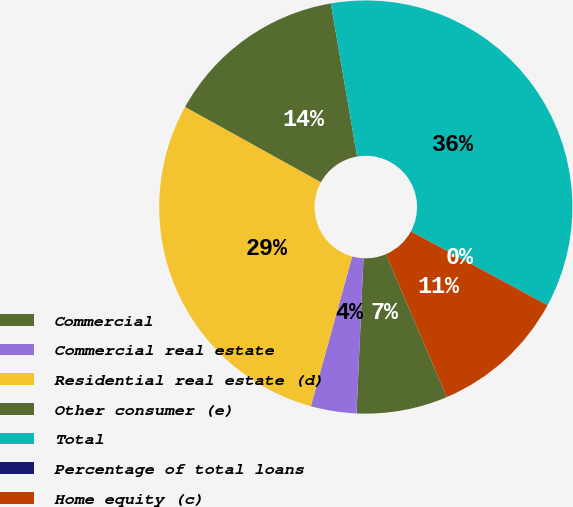<chart> <loc_0><loc_0><loc_500><loc_500><pie_chart><fcel>Commercial<fcel>Commercial real estate<fcel>Residential real estate (d)<fcel>Other consumer (e)<fcel>Total<fcel>Percentage of total loans<fcel>Home equity (c)<nl><fcel>7.13%<fcel>3.57%<fcel>28.77%<fcel>14.24%<fcel>35.58%<fcel>0.02%<fcel>10.69%<nl></chart> 